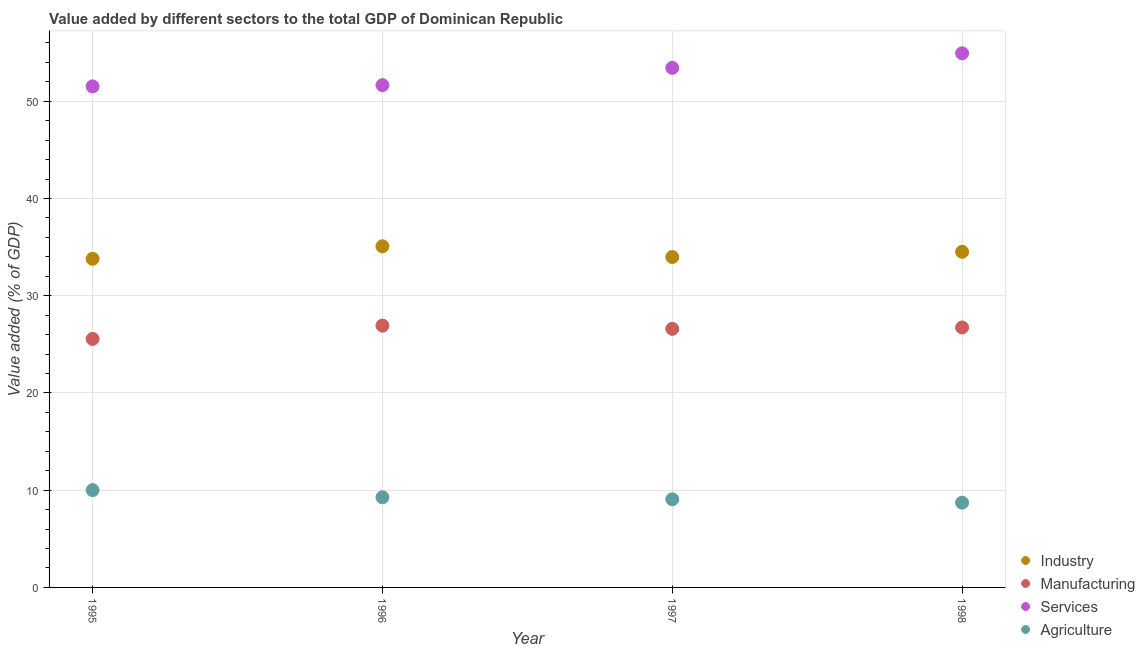How many different coloured dotlines are there?
Provide a short and direct response. 4. What is the value added by manufacturing sector in 1997?
Provide a short and direct response. 26.59. Across all years, what is the maximum value added by manufacturing sector?
Offer a very short reply. 26.93. Across all years, what is the minimum value added by services sector?
Provide a succinct answer. 51.53. What is the total value added by industrial sector in the graph?
Provide a succinct answer. 137.38. What is the difference between the value added by agricultural sector in 1995 and that in 1996?
Your response must be concise. 0.73. What is the difference between the value added by manufacturing sector in 1997 and the value added by agricultural sector in 1995?
Offer a terse response. 16.59. What is the average value added by agricultural sector per year?
Offer a very short reply. 9.26. In the year 1995, what is the difference between the value added by industrial sector and value added by services sector?
Make the answer very short. -17.73. In how many years, is the value added by industrial sector greater than 44 %?
Keep it short and to the point. 0. What is the ratio of the value added by services sector in 1995 to that in 1997?
Make the answer very short. 0.96. Is the value added by industrial sector in 1995 less than that in 1996?
Offer a very short reply. Yes. What is the difference between the highest and the second highest value added by agricultural sector?
Make the answer very short. 0.73. What is the difference between the highest and the lowest value added by services sector?
Offer a very short reply. 3.4. Is it the case that in every year, the sum of the value added by industrial sector and value added by manufacturing sector is greater than the value added by services sector?
Make the answer very short. Yes. Does the value added by agricultural sector monotonically increase over the years?
Your answer should be very brief. No. How many dotlines are there?
Provide a succinct answer. 4. How many years are there in the graph?
Your answer should be very brief. 4. What is the difference between two consecutive major ticks on the Y-axis?
Make the answer very short. 10. Are the values on the major ticks of Y-axis written in scientific E-notation?
Your answer should be compact. No. Where does the legend appear in the graph?
Your response must be concise. Bottom right. How are the legend labels stacked?
Your response must be concise. Vertical. What is the title of the graph?
Keep it short and to the point. Value added by different sectors to the total GDP of Dominican Republic. Does "Secondary schools" appear as one of the legend labels in the graph?
Provide a succinct answer. No. What is the label or title of the Y-axis?
Ensure brevity in your answer.  Value added (% of GDP). What is the Value added (% of GDP) of Industry in 1995?
Provide a succinct answer. 33.8. What is the Value added (% of GDP) of Manufacturing in 1995?
Make the answer very short. 25.56. What is the Value added (% of GDP) of Services in 1995?
Provide a succinct answer. 51.53. What is the Value added (% of GDP) in Agriculture in 1995?
Keep it short and to the point. 10.01. What is the Value added (% of GDP) in Industry in 1996?
Offer a very short reply. 35.08. What is the Value added (% of GDP) of Manufacturing in 1996?
Offer a terse response. 26.93. What is the Value added (% of GDP) in Services in 1996?
Ensure brevity in your answer.  51.66. What is the Value added (% of GDP) of Agriculture in 1996?
Give a very brief answer. 9.27. What is the Value added (% of GDP) of Industry in 1997?
Your answer should be compact. 33.98. What is the Value added (% of GDP) in Manufacturing in 1997?
Make the answer very short. 26.59. What is the Value added (% of GDP) of Services in 1997?
Ensure brevity in your answer.  53.44. What is the Value added (% of GDP) in Agriculture in 1997?
Offer a very short reply. 9.06. What is the Value added (% of GDP) of Industry in 1998?
Offer a very short reply. 34.52. What is the Value added (% of GDP) of Manufacturing in 1998?
Give a very brief answer. 26.74. What is the Value added (% of GDP) in Services in 1998?
Your response must be concise. 54.93. What is the Value added (% of GDP) in Agriculture in 1998?
Your answer should be very brief. 8.72. Across all years, what is the maximum Value added (% of GDP) of Industry?
Provide a succinct answer. 35.08. Across all years, what is the maximum Value added (% of GDP) in Manufacturing?
Make the answer very short. 26.93. Across all years, what is the maximum Value added (% of GDP) in Services?
Your response must be concise. 54.93. Across all years, what is the maximum Value added (% of GDP) in Agriculture?
Provide a short and direct response. 10.01. Across all years, what is the minimum Value added (% of GDP) in Industry?
Make the answer very short. 33.8. Across all years, what is the minimum Value added (% of GDP) of Manufacturing?
Provide a short and direct response. 25.56. Across all years, what is the minimum Value added (% of GDP) of Services?
Your answer should be compact. 51.53. Across all years, what is the minimum Value added (% of GDP) in Agriculture?
Ensure brevity in your answer.  8.72. What is the total Value added (% of GDP) of Industry in the graph?
Your answer should be very brief. 137.38. What is the total Value added (% of GDP) of Manufacturing in the graph?
Your response must be concise. 105.82. What is the total Value added (% of GDP) in Services in the graph?
Provide a succinct answer. 211.56. What is the total Value added (% of GDP) of Agriculture in the graph?
Make the answer very short. 37.06. What is the difference between the Value added (% of GDP) in Industry in 1995 and that in 1996?
Offer a very short reply. -1.29. What is the difference between the Value added (% of GDP) of Manufacturing in 1995 and that in 1996?
Keep it short and to the point. -1.37. What is the difference between the Value added (% of GDP) in Services in 1995 and that in 1996?
Provide a short and direct response. -0.12. What is the difference between the Value added (% of GDP) in Agriculture in 1995 and that in 1996?
Offer a very short reply. 0.73. What is the difference between the Value added (% of GDP) in Industry in 1995 and that in 1997?
Keep it short and to the point. -0.19. What is the difference between the Value added (% of GDP) of Manufacturing in 1995 and that in 1997?
Offer a very short reply. -1.04. What is the difference between the Value added (% of GDP) in Services in 1995 and that in 1997?
Ensure brevity in your answer.  -1.91. What is the difference between the Value added (% of GDP) in Agriculture in 1995 and that in 1997?
Your response must be concise. 0.94. What is the difference between the Value added (% of GDP) of Industry in 1995 and that in 1998?
Offer a terse response. -0.72. What is the difference between the Value added (% of GDP) in Manufacturing in 1995 and that in 1998?
Provide a succinct answer. -1.18. What is the difference between the Value added (% of GDP) of Services in 1995 and that in 1998?
Your answer should be very brief. -3.4. What is the difference between the Value added (% of GDP) in Agriculture in 1995 and that in 1998?
Make the answer very short. 1.29. What is the difference between the Value added (% of GDP) in Industry in 1996 and that in 1997?
Provide a succinct answer. 1.1. What is the difference between the Value added (% of GDP) in Manufacturing in 1996 and that in 1997?
Your response must be concise. 0.33. What is the difference between the Value added (% of GDP) in Services in 1996 and that in 1997?
Offer a very short reply. -1.78. What is the difference between the Value added (% of GDP) in Agriculture in 1996 and that in 1997?
Ensure brevity in your answer.  0.21. What is the difference between the Value added (% of GDP) of Industry in 1996 and that in 1998?
Keep it short and to the point. 0.57. What is the difference between the Value added (% of GDP) of Manufacturing in 1996 and that in 1998?
Give a very brief answer. 0.19. What is the difference between the Value added (% of GDP) in Services in 1996 and that in 1998?
Your response must be concise. -3.28. What is the difference between the Value added (% of GDP) in Agriculture in 1996 and that in 1998?
Offer a terse response. 0.55. What is the difference between the Value added (% of GDP) of Industry in 1997 and that in 1998?
Give a very brief answer. -0.54. What is the difference between the Value added (% of GDP) in Manufacturing in 1997 and that in 1998?
Ensure brevity in your answer.  -0.14. What is the difference between the Value added (% of GDP) of Services in 1997 and that in 1998?
Your answer should be compact. -1.5. What is the difference between the Value added (% of GDP) of Agriculture in 1997 and that in 1998?
Ensure brevity in your answer.  0.35. What is the difference between the Value added (% of GDP) in Industry in 1995 and the Value added (% of GDP) in Manufacturing in 1996?
Give a very brief answer. 6.87. What is the difference between the Value added (% of GDP) of Industry in 1995 and the Value added (% of GDP) of Services in 1996?
Give a very brief answer. -17.86. What is the difference between the Value added (% of GDP) in Industry in 1995 and the Value added (% of GDP) in Agriculture in 1996?
Ensure brevity in your answer.  24.52. What is the difference between the Value added (% of GDP) of Manufacturing in 1995 and the Value added (% of GDP) of Services in 1996?
Keep it short and to the point. -26.1. What is the difference between the Value added (% of GDP) in Manufacturing in 1995 and the Value added (% of GDP) in Agriculture in 1996?
Offer a very short reply. 16.29. What is the difference between the Value added (% of GDP) of Services in 1995 and the Value added (% of GDP) of Agriculture in 1996?
Offer a very short reply. 42.26. What is the difference between the Value added (% of GDP) of Industry in 1995 and the Value added (% of GDP) of Manufacturing in 1997?
Your response must be concise. 7.2. What is the difference between the Value added (% of GDP) in Industry in 1995 and the Value added (% of GDP) in Services in 1997?
Your answer should be compact. -19.64. What is the difference between the Value added (% of GDP) in Industry in 1995 and the Value added (% of GDP) in Agriculture in 1997?
Your answer should be very brief. 24.73. What is the difference between the Value added (% of GDP) in Manufacturing in 1995 and the Value added (% of GDP) in Services in 1997?
Give a very brief answer. -27.88. What is the difference between the Value added (% of GDP) of Manufacturing in 1995 and the Value added (% of GDP) of Agriculture in 1997?
Make the answer very short. 16.49. What is the difference between the Value added (% of GDP) in Services in 1995 and the Value added (% of GDP) in Agriculture in 1997?
Offer a very short reply. 42.47. What is the difference between the Value added (% of GDP) in Industry in 1995 and the Value added (% of GDP) in Manufacturing in 1998?
Offer a very short reply. 7.06. What is the difference between the Value added (% of GDP) of Industry in 1995 and the Value added (% of GDP) of Services in 1998?
Ensure brevity in your answer.  -21.14. What is the difference between the Value added (% of GDP) in Industry in 1995 and the Value added (% of GDP) in Agriculture in 1998?
Keep it short and to the point. 25.08. What is the difference between the Value added (% of GDP) of Manufacturing in 1995 and the Value added (% of GDP) of Services in 1998?
Offer a terse response. -29.38. What is the difference between the Value added (% of GDP) in Manufacturing in 1995 and the Value added (% of GDP) in Agriculture in 1998?
Provide a succinct answer. 16.84. What is the difference between the Value added (% of GDP) in Services in 1995 and the Value added (% of GDP) in Agriculture in 1998?
Give a very brief answer. 42.81. What is the difference between the Value added (% of GDP) of Industry in 1996 and the Value added (% of GDP) of Manufacturing in 1997?
Provide a short and direct response. 8.49. What is the difference between the Value added (% of GDP) of Industry in 1996 and the Value added (% of GDP) of Services in 1997?
Ensure brevity in your answer.  -18.35. What is the difference between the Value added (% of GDP) in Industry in 1996 and the Value added (% of GDP) in Agriculture in 1997?
Keep it short and to the point. 26.02. What is the difference between the Value added (% of GDP) of Manufacturing in 1996 and the Value added (% of GDP) of Services in 1997?
Offer a very short reply. -26.51. What is the difference between the Value added (% of GDP) in Manufacturing in 1996 and the Value added (% of GDP) in Agriculture in 1997?
Ensure brevity in your answer.  17.86. What is the difference between the Value added (% of GDP) in Services in 1996 and the Value added (% of GDP) in Agriculture in 1997?
Provide a succinct answer. 42.59. What is the difference between the Value added (% of GDP) in Industry in 1996 and the Value added (% of GDP) in Manufacturing in 1998?
Keep it short and to the point. 8.35. What is the difference between the Value added (% of GDP) of Industry in 1996 and the Value added (% of GDP) of Services in 1998?
Your answer should be very brief. -19.85. What is the difference between the Value added (% of GDP) in Industry in 1996 and the Value added (% of GDP) in Agriculture in 1998?
Your answer should be very brief. 26.37. What is the difference between the Value added (% of GDP) in Manufacturing in 1996 and the Value added (% of GDP) in Services in 1998?
Offer a terse response. -28.01. What is the difference between the Value added (% of GDP) of Manufacturing in 1996 and the Value added (% of GDP) of Agriculture in 1998?
Ensure brevity in your answer.  18.21. What is the difference between the Value added (% of GDP) in Services in 1996 and the Value added (% of GDP) in Agriculture in 1998?
Ensure brevity in your answer.  42.94. What is the difference between the Value added (% of GDP) in Industry in 1997 and the Value added (% of GDP) in Manufacturing in 1998?
Ensure brevity in your answer.  7.25. What is the difference between the Value added (% of GDP) in Industry in 1997 and the Value added (% of GDP) in Services in 1998?
Offer a very short reply. -20.95. What is the difference between the Value added (% of GDP) of Industry in 1997 and the Value added (% of GDP) of Agriculture in 1998?
Your response must be concise. 25.27. What is the difference between the Value added (% of GDP) in Manufacturing in 1997 and the Value added (% of GDP) in Services in 1998?
Provide a succinct answer. -28.34. What is the difference between the Value added (% of GDP) in Manufacturing in 1997 and the Value added (% of GDP) in Agriculture in 1998?
Give a very brief answer. 17.88. What is the difference between the Value added (% of GDP) in Services in 1997 and the Value added (% of GDP) in Agriculture in 1998?
Your answer should be very brief. 44.72. What is the average Value added (% of GDP) of Industry per year?
Your response must be concise. 34.35. What is the average Value added (% of GDP) of Manufacturing per year?
Give a very brief answer. 26.45. What is the average Value added (% of GDP) in Services per year?
Give a very brief answer. 52.89. What is the average Value added (% of GDP) in Agriculture per year?
Your response must be concise. 9.26. In the year 1995, what is the difference between the Value added (% of GDP) of Industry and Value added (% of GDP) of Manufacturing?
Give a very brief answer. 8.24. In the year 1995, what is the difference between the Value added (% of GDP) of Industry and Value added (% of GDP) of Services?
Offer a terse response. -17.73. In the year 1995, what is the difference between the Value added (% of GDP) in Industry and Value added (% of GDP) in Agriculture?
Offer a terse response. 23.79. In the year 1995, what is the difference between the Value added (% of GDP) in Manufacturing and Value added (% of GDP) in Services?
Offer a very short reply. -25.97. In the year 1995, what is the difference between the Value added (% of GDP) in Manufacturing and Value added (% of GDP) in Agriculture?
Provide a succinct answer. 15.55. In the year 1995, what is the difference between the Value added (% of GDP) of Services and Value added (% of GDP) of Agriculture?
Provide a succinct answer. 41.52. In the year 1996, what is the difference between the Value added (% of GDP) of Industry and Value added (% of GDP) of Manufacturing?
Your answer should be very brief. 8.16. In the year 1996, what is the difference between the Value added (% of GDP) in Industry and Value added (% of GDP) in Services?
Provide a short and direct response. -16.57. In the year 1996, what is the difference between the Value added (% of GDP) of Industry and Value added (% of GDP) of Agriculture?
Offer a very short reply. 25.81. In the year 1996, what is the difference between the Value added (% of GDP) of Manufacturing and Value added (% of GDP) of Services?
Offer a very short reply. -24.73. In the year 1996, what is the difference between the Value added (% of GDP) of Manufacturing and Value added (% of GDP) of Agriculture?
Make the answer very short. 17.66. In the year 1996, what is the difference between the Value added (% of GDP) of Services and Value added (% of GDP) of Agriculture?
Your answer should be compact. 42.38. In the year 1997, what is the difference between the Value added (% of GDP) in Industry and Value added (% of GDP) in Manufacturing?
Keep it short and to the point. 7.39. In the year 1997, what is the difference between the Value added (% of GDP) in Industry and Value added (% of GDP) in Services?
Provide a succinct answer. -19.45. In the year 1997, what is the difference between the Value added (% of GDP) of Industry and Value added (% of GDP) of Agriculture?
Provide a short and direct response. 24.92. In the year 1997, what is the difference between the Value added (% of GDP) of Manufacturing and Value added (% of GDP) of Services?
Provide a short and direct response. -26.84. In the year 1997, what is the difference between the Value added (% of GDP) of Manufacturing and Value added (% of GDP) of Agriculture?
Make the answer very short. 17.53. In the year 1997, what is the difference between the Value added (% of GDP) in Services and Value added (% of GDP) in Agriculture?
Your response must be concise. 44.37. In the year 1998, what is the difference between the Value added (% of GDP) of Industry and Value added (% of GDP) of Manufacturing?
Your answer should be compact. 7.78. In the year 1998, what is the difference between the Value added (% of GDP) of Industry and Value added (% of GDP) of Services?
Offer a very short reply. -20.41. In the year 1998, what is the difference between the Value added (% of GDP) in Industry and Value added (% of GDP) in Agriculture?
Make the answer very short. 25.8. In the year 1998, what is the difference between the Value added (% of GDP) of Manufacturing and Value added (% of GDP) of Services?
Give a very brief answer. -28.2. In the year 1998, what is the difference between the Value added (% of GDP) of Manufacturing and Value added (% of GDP) of Agriculture?
Make the answer very short. 18.02. In the year 1998, what is the difference between the Value added (% of GDP) of Services and Value added (% of GDP) of Agriculture?
Give a very brief answer. 46.22. What is the ratio of the Value added (% of GDP) in Industry in 1995 to that in 1996?
Make the answer very short. 0.96. What is the ratio of the Value added (% of GDP) of Manufacturing in 1995 to that in 1996?
Your answer should be compact. 0.95. What is the ratio of the Value added (% of GDP) of Agriculture in 1995 to that in 1996?
Your answer should be compact. 1.08. What is the ratio of the Value added (% of GDP) of Agriculture in 1995 to that in 1997?
Offer a very short reply. 1.1. What is the ratio of the Value added (% of GDP) in Industry in 1995 to that in 1998?
Offer a terse response. 0.98. What is the ratio of the Value added (% of GDP) of Manufacturing in 1995 to that in 1998?
Provide a short and direct response. 0.96. What is the ratio of the Value added (% of GDP) of Services in 1995 to that in 1998?
Give a very brief answer. 0.94. What is the ratio of the Value added (% of GDP) of Agriculture in 1995 to that in 1998?
Your answer should be very brief. 1.15. What is the ratio of the Value added (% of GDP) in Industry in 1996 to that in 1997?
Your response must be concise. 1.03. What is the ratio of the Value added (% of GDP) in Manufacturing in 1996 to that in 1997?
Provide a succinct answer. 1.01. What is the ratio of the Value added (% of GDP) of Services in 1996 to that in 1997?
Your answer should be compact. 0.97. What is the ratio of the Value added (% of GDP) of Agriculture in 1996 to that in 1997?
Your answer should be compact. 1.02. What is the ratio of the Value added (% of GDP) of Industry in 1996 to that in 1998?
Offer a very short reply. 1.02. What is the ratio of the Value added (% of GDP) in Manufacturing in 1996 to that in 1998?
Your answer should be compact. 1.01. What is the ratio of the Value added (% of GDP) in Services in 1996 to that in 1998?
Provide a short and direct response. 0.94. What is the ratio of the Value added (% of GDP) in Agriculture in 1996 to that in 1998?
Your response must be concise. 1.06. What is the ratio of the Value added (% of GDP) in Industry in 1997 to that in 1998?
Provide a succinct answer. 0.98. What is the ratio of the Value added (% of GDP) of Services in 1997 to that in 1998?
Ensure brevity in your answer.  0.97. What is the ratio of the Value added (% of GDP) of Agriculture in 1997 to that in 1998?
Provide a succinct answer. 1.04. What is the difference between the highest and the second highest Value added (% of GDP) in Industry?
Offer a very short reply. 0.57. What is the difference between the highest and the second highest Value added (% of GDP) of Manufacturing?
Provide a short and direct response. 0.19. What is the difference between the highest and the second highest Value added (% of GDP) in Services?
Your answer should be very brief. 1.5. What is the difference between the highest and the second highest Value added (% of GDP) in Agriculture?
Offer a terse response. 0.73. What is the difference between the highest and the lowest Value added (% of GDP) of Industry?
Provide a succinct answer. 1.29. What is the difference between the highest and the lowest Value added (% of GDP) of Manufacturing?
Offer a terse response. 1.37. What is the difference between the highest and the lowest Value added (% of GDP) of Services?
Ensure brevity in your answer.  3.4. What is the difference between the highest and the lowest Value added (% of GDP) in Agriculture?
Give a very brief answer. 1.29. 